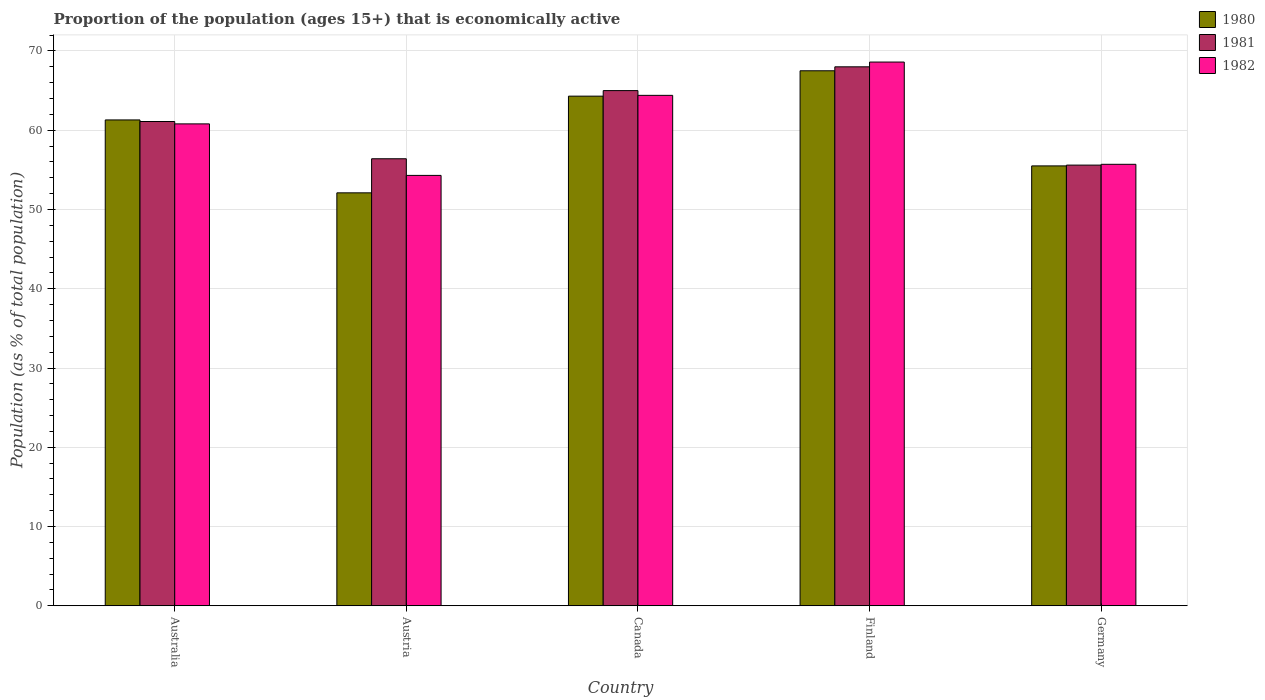How many groups of bars are there?
Provide a short and direct response. 5. How many bars are there on the 1st tick from the left?
Provide a short and direct response. 3. What is the label of the 3rd group of bars from the left?
Make the answer very short. Canada. In how many cases, is the number of bars for a given country not equal to the number of legend labels?
Make the answer very short. 0. Across all countries, what is the maximum proportion of the population that is economically active in 1982?
Keep it short and to the point. 68.6. Across all countries, what is the minimum proportion of the population that is economically active in 1982?
Make the answer very short. 54.3. In which country was the proportion of the population that is economically active in 1981 maximum?
Offer a terse response. Finland. What is the total proportion of the population that is economically active in 1982 in the graph?
Ensure brevity in your answer.  303.8. What is the difference between the proportion of the population that is economically active in 1981 in Finland and that in Germany?
Make the answer very short. 12.4. What is the difference between the proportion of the population that is economically active in 1982 in Canada and the proportion of the population that is economically active in 1980 in Germany?
Offer a very short reply. 8.9. What is the average proportion of the population that is economically active in 1981 per country?
Offer a terse response. 61.22. What is the difference between the proportion of the population that is economically active of/in 1981 and proportion of the population that is economically active of/in 1982 in Austria?
Your response must be concise. 2.1. What is the ratio of the proportion of the population that is economically active in 1981 in Austria to that in Canada?
Keep it short and to the point. 0.87. Is the proportion of the population that is economically active in 1982 in Australia less than that in Finland?
Your response must be concise. Yes. Is the difference between the proportion of the population that is economically active in 1981 in Canada and Finland greater than the difference between the proportion of the population that is economically active in 1982 in Canada and Finland?
Keep it short and to the point. Yes. What is the difference between the highest and the lowest proportion of the population that is economically active in 1981?
Your response must be concise. 12.4. In how many countries, is the proportion of the population that is economically active in 1980 greater than the average proportion of the population that is economically active in 1980 taken over all countries?
Keep it short and to the point. 3. Is the sum of the proportion of the population that is economically active in 1982 in Australia and Canada greater than the maximum proportion of the population that is economically active in 1980 across all countries?
Offer a very short reply. Yes. What does the 1st bar from the left in Austria represents?
Your answer should be compact. 1980. Is it the case that in every country, the sum of the proportion of the population that is economically active in 1981 and proportion of the population that is economically active in 1980 is greater than the proportion of the population that is economically active in 1982?
Ensure brevity in your answer.  Yes. How many countries are there in the graph?
Keep it short and to the point. 5. What is the difference between two consecutive major ticks on the Y-axis?
Your answer should be compact. 10. Are the values on the major ticks of Y-axis written in scientific E-notation?
Your answer should be compact. No. Does the graph contain grids?
Offer a very short reply. Yes. Where does the legend appear in the graph?
Provide a succinct answer. Top right. How many legend labels are there?
Your answer should be compact. 3. How are the legend labels stacked?
Keep it short and to the point. Vertical. What is the title of the graph?
Your answer should be compact. Proportion of the population (ages 15+) that is economically active. Does "1977" appear as one of the legend labels in the graph?
Your answer should be very brief. No. What is the label or title of the Y-axis?
Your response must be concise. Population (as % of total population). What is the Population (as % of total population) in 1980 in Australia?
Your answer should be very brief. 61.3. What is the Population (as % of total population) of 1981 in Australia?
Provide a short and direct response. 61.1. What is the Population (as % of total population) of 1982 in Australia?
Your answer should be compact. 60.8. What is the Population (as % of total population) of 1980 in Austria?
Provide a short and direct response. 52.1. What is the Population (as % of total population) of 1981 in Austria?
Your response must be concise. 56.4. What is the Population (as % of total population) of 1982 in Austria?
Keep it short and to the point. 54.3. What is the Population (as % of total population) of 1980 in Canada?
Your answer should be very brief. 64.3. What is the Population (as % of total population) in 1981 in Canada?
Your response must be concise. 65. What is the Population (as % of total population) of 1982 in Canada?
Your answer should be very brief. 64.4. What is the Population (as % of total population) in 1980 in Finland?
Give a very brief answer. 67.5. What is the Population (as % of total population) in 1982 in Finland?
Give a very brief answer. 68.6. What is the Population (as % of total population) of 1980 in Germany?
Provide a short and direct response. 55.5. What is the Population (as % of total population) of 1981 in Germany?
Offer a very short reply. 55.6. What is the Population (as % of total population) in 1982 in Germany?
Make the answer very short. 55.7. Across all countries, what is the maximum Population (as % of total population) in 1980?
Your response must be concise. 67.5. Across all countries, what is the maximum Population (as % of total population) of 1981?
Your answer should be compact. 68. Across all countries, what is the maximum Population (as % of total population) in 1982?
Offer a terse response. 68.6. Across all countries, what is the minimum Population (as % of total population) of 1980?
Your response must be concise. 52.1. Across all countries, what is the minimum Population (as % of total population) in 1981?
Provide a short and direct response. 55.6. Across all countries, what is the minimum Population (as % of total population) of 1982?
Your answer should be very brief. 54.3. What is the total Population (as % of total population) of 1980 in the graph?
Give a very brief answer. 300.7. What is the total Population (as % of total population) of 1981 in the graph?
Provide a succinct answer. 306.1. What is the total Population (as % of total population) of 1982 in the graph?
Your response must be concise. 303.8. What is the difference between the Population (as % of total population) in 1980 in Australia and that in Canada?
Your response must be concise. -3. What is the difference between the Population (as % of total population) in 1981 in Australia and that in Canada?
Provide a short and direct response. -3.9. What is the difference between the Population (as % of total population) of 1982 in Australia and that in Canada?
Provide a short and direct response. -3.6. What is the difference between the Population (as % of total population) in 1980 in Australia and that in Finland?
Keep it short and to the point. -6.2. What is the difference between the Population (as % of total population) of 1981 in Australia and that in Finland?
Your response must be concise. -6.9. What is the difference between the Population (as % of total population) of 1982 in Australia and that in Finland?
Your answer should be compact. -7.8. What is the difference between the Population (as % of total population) in 1980 in Australia and that in Germany?
Provide a succinct answer. 5.8. What is the difference between the Population (as % of total population) in 1980 in Austria and that in Canada?
Provide a short and direct response. -12.2. What is the difference between the Population (as % of total population) of 1981 in Austria and that in Canada?
Offer a terse response. -8.6. What is the difference between the Population (as % of total population) of 1982 in Austria and that in Canada?
Give a very brief answer. -10.1. What is the difference between the Population (as % of total population) in 1980 in Austria and that in Finland?
Provide a succinct answer. -15.4. What is the difference between the Population (as % of total population) in 1981 in Austria and that in Finland?
Your answer should be very brief. -11.6. What is the difference between the Population (as % of total population) of 1982 in Austria and that in Finland?
Provide a succinct answer. -14.3. What is the difference between the Population (as % of total population) of 1980 in Austria and that in Germany?
Offer a terse response. -3.4. What is the difference between the Population (as % of total population) in 1981 in Austria and that in Germany?
Make the answer very short. 0.8. What is the difference between the Population (as % of total population) in 1980 in Canada and that in Finland?
Your answer should be very brief. -3.2. What is the difference between the Population (as % of total population) of 1981 in Canada and that in Finland?
Offer a terse response. -3. What is the difference between the Population (as % of total population) of 1982 in Canada and that in Finland?
Keep it short and to the point. -4.2. What is the difference between the Population (as % of total population) of 1980 in Finland and that in Germany?
Make the answer very short. 12. What is the difference between the Population (as % of total population) in 1982 in Finland and that in Germany?
Your answer should be compact. 12.9. What is the difference between the Population (as % of total population) of 1980 in Australia and the Population (as % of total population) of 1982 in Austria?
Your answer should be compact. 7. What is the difference between the Population (as % of total population) of 1980 in Australia and the Population (as % of total population) of 1981 in Canada?
Offer a very short reply. -3.7. What is the difference between the Population (as % of total population) in 1980 in Australia and the Population (as % of total population) in 1982 in Finland?
Give a very brief answer. -7.3. What is the difference between the Population (as % of total population) of 1981 in Australia and the Population (as % of total population) of 1982 in Germany?
Provide a succinct answer. 5.4. What is the difference between the Population (as % of total population) of 1980 in Austria and the Population (as % of total population) of 1981 in Canada?
Your response must be concise. -12.9. What is the difference between the Population (as % of total population) in 1980 in Austria and the Population (as % of total population) in 1982 in Canada?
Give a very brief answer. -12.3. What is the difference between the Population (as % of total population) of 1980 in Austria and the Population (as % of total population) of 1981 in Finland?
Provide a succinct answer. -15.9. What is the difference between the Population (as % of total population) in 1980 in Austria and the Population (as % of total population) in 1982 in Finland?
Ensure brevity in your answer.  -16.5. What is the difference between the Population (as % of total population) in 1981 in Austria and the Population (as % of total population) in 1982 in Finland?
Ensure brevity in your answer.  -12.2. What is the difference between the Population (as % of total population) in 1980 in Austria and the Population (as % of total population) in 1982 in Germany?
Offer a very short reply. -3.6. What is the difference between the Population (as % of total population) of 1980 in Canada and the Population (as % of total population) of 1982 in Germany?
Offer a very short reply. 8.6. What is the difference between the Population (as % of total population) of 1980 in Finland and the Population (as % of total population) of 1982 in Germany?
Your response must be concise. 11.8. What is the difference between the Population (as % of total population) of 1981 in Finland and the Population (as % of total population) of 1982 in Germany?
Ensure brevity in your answer.  12.3. What is the average Population (as % of total population) in 1980 per country?
Offer a terse response. 60.14. What is the average Population (as % of total population) in 1981 per country?
Offer a terse response. 61.22. What is the average Population (as % of total population) of 1982 per country?
Keep it short and to the point. 60.76. What is the difference between the Population (as % of total population) of 1980 and Population (as % of total population) of 1981 in Australia?
Keep it short and to the point. 0.2. What is the difference between the Population (as % of total population) in 1980 and Population (as % of total population) in 1982 in Australia?
Your response must be concise. 0.5. What is the difference between the Population (as % of total population) of 1981 and Population (as % of total population) of 1982 in Australia?
Your answer should be compact. 0.3. What is the difference between the Population (as % of total population) in 1980 and Population (as % of total population) in 1982 in Austria?
Offer a terse response. -2.2. What is the difference between the Population (as % of total population) in 1981 and Population (as % of total population) in 1982 in Austria?
Ensure brevity in your answer.  2.1. What is the difference between the Population (as % of total population) in 1981 and Population (as % of total population) in 1982 in Canada?
Your response must be concise. 0.6. What is the difference between the Population (as % of total population) in 1981 and Population (as % of total population) in 1982 in Finland?
Offer a very short reply. -0.6. What is the difference between the Population (as % of total population) in 1980 and Population (as % of total population) in 1981 in Germany?
Ensure brevity in your answer.  -0.1. What is the ratio of the Population (as % of total population) of 1980 in Australia to that in Austria?
Offer a very short reply. 1.18. What is the ratio of the Population (as % of total population) of 1982 in Australia to that in Austria?
Offer a very short reply. 1.12. What is the ratio of the Population (as % of total population) of 1980 in Australia to that in Canada?
Offer a terse response. 0.95. What is the ratio of the Population (as % of total population) in 1981 in Australia to that in Canada?
Provide a succinct answer. 0.94. What is the ratio of the Population (as % of total population) of 1982 in Australia to that in Canada?
Offer a terse response. 0.94. What is the ratio of the Population (as % of total population) of 1980 in Australia to that in Finland?
Your answer should be compact. 0.91. What is the ratio of the Population (as % of total population) of 1981 in Australia to that in Finland?
Ensure brevity in your answer.  0.9. What is the ratio of the Population (as % of total population) in 1982 in Australia to that in Finland?
Offer a terse response. 0.89. What is the ratio of the Population (as % of total population) of 1980 in Australia to that in Germany?
Your answer should be compact. 1.1. What is the ratio of the Population (as % of total population) of 1981 in Australia to that in Germany?
Provide a succinct answer. 1.1. What is the ratio of the Population (as % of total population) of 1982 in Australia to that in Germany?
Offer a terse response. 1.09. What is the ratio of the Population (as % of total population) of 1980 in Austria to that in Canada?
Provide a short and direct response. 0.81. What is the ratio of the Population (as % of total population) in 1981 in Austria to that in Canada?
Give a very brief answer. 0.87. What is the ratio of the Population (as % of total population) of 1982 in Austria to that in Canada?
Provide a short and direct response. 0.84. What is the ratio of the Population (as % of total population) of 1980 in Austria to that in Finland?
Provide a short and direct response. 0.77. What is the ratio of the Population (as % of total population) of 1981 in Austria to that in Finland?
Offer a very short reply. 0.83. What is the ratio of the Population (as % of total population) in 1982 in Austria to that in Finland?
Your response must be concise. 0.79. What is the ratio of the Population (as % of total population) in 1980 in Austria to that in Germany?
Make the answer very short. 0.94. What is the ratio of the Population (as % of total population) in 1981 in Austria to that in Germany?
Your answer should be very brief. 1.01. What is the ratio of the Population (as % of total population) of 1982 in Austria to that in Germany?
Offer a very short reply. 0.97. What is the ratio of the Population (as % of total population) of 1980 in Canada to that in Finland?
Offer a terse response. 0.95. What is the ratio of the Population (as % of total population) of 1981 in Canada to that in Finland?
Provide a short and direct response. 0.96. What is the ratio of the Population (as % of total population) of 1982 in Canada to that in Finland?
Ensure brevity in your answer.  0.94. What is the ratio of the Population (as % of total population) of 1980 in Canada to that in Germany?
Keep it short and to the point. 1.16. What is the ratio of the Population (as % of total population) in 1981 in Canada to that in Germany?
Provide a short and direct response. 1.17. What is the ratio of the Population (as % of total population) in 1982 in Canada to that in Germany?
Your answer should be very brief. 1.16. What is the ratio of the Population (as % of total population) in 1980 in Finland to that in Germany?
Keep it short and to the point. 1.22. What is the ratio of the Population (as % of total population) of 1981 in Finland to that in Germany?
Keep it short and to the point. 1.22. What is the ratio of the Population (as % of total population) of 1982 in Finland to that in Germany?
Your answer should be very brief. 1.23. What is the difference between the highest and the second highest Population (as % of total population) of 1982?
Give a very brief answer. 4.2. 